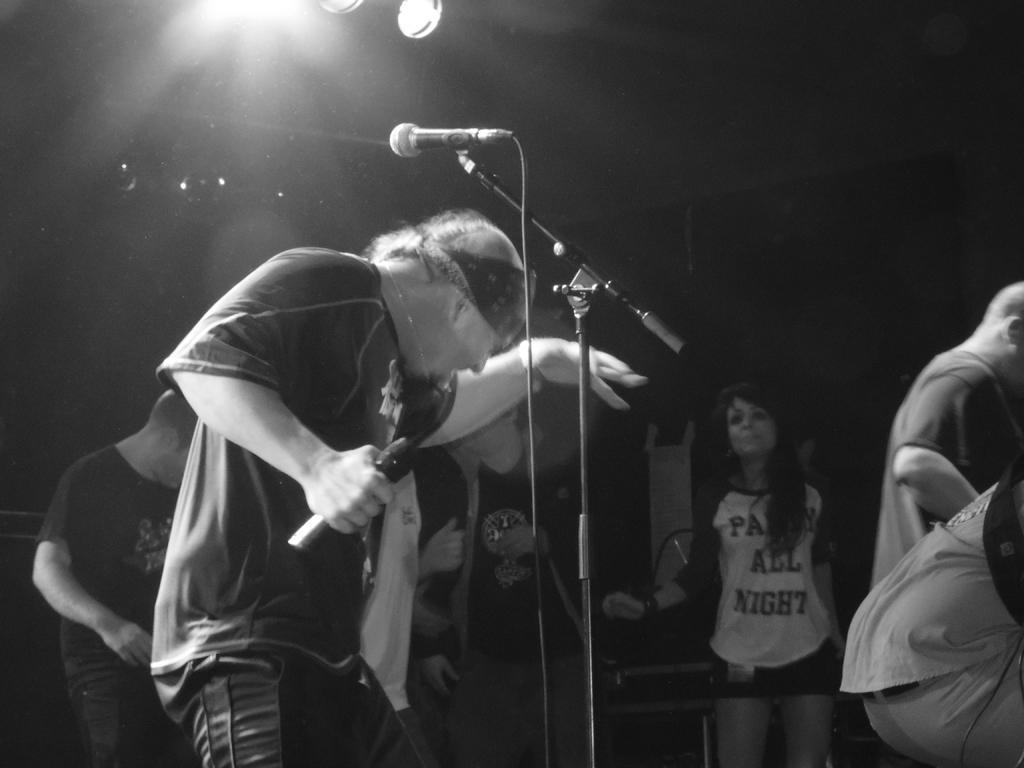In one or two sentences, can you explain what this image depicts? In this image a person is holding one mic. There are few people around the person. In front of him there is a mic. 